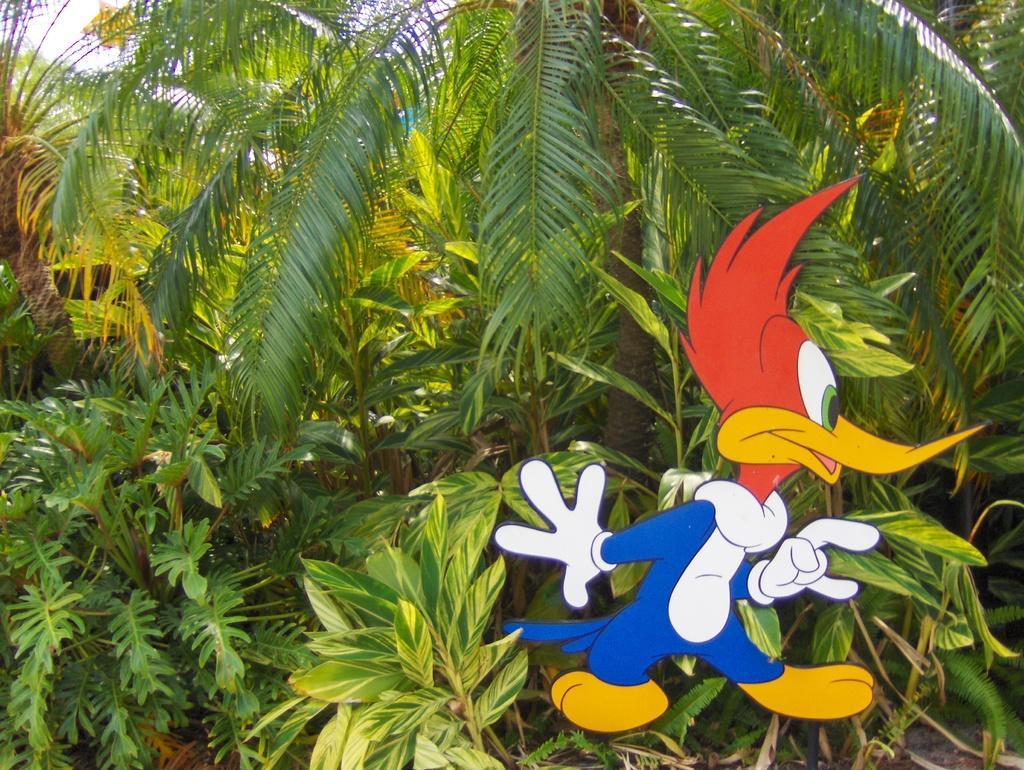Could you give a brief overview of what you see in this image? In this image, we can see a picture of a cartoon and in the background, there are trees. 